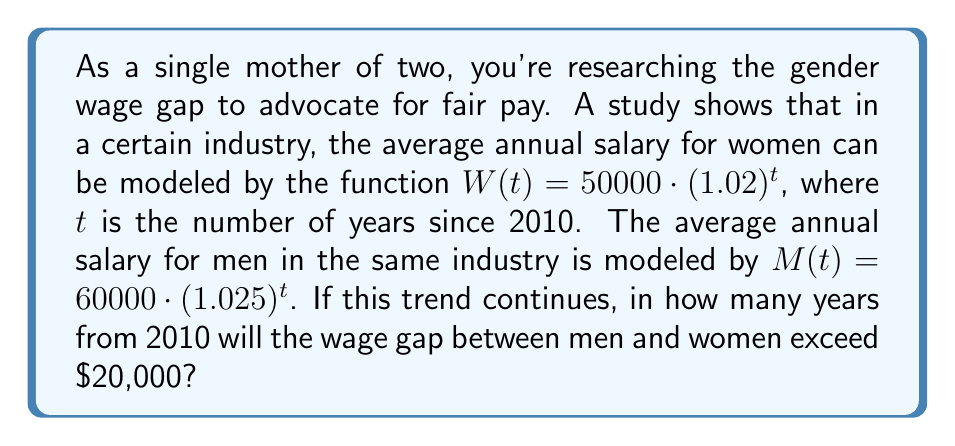Solve this math problem. To solve this problem, we need to follow these steps:

1) First, let's set up an inequality to represent when the wage gap exceeds $20,000:

   $M(t) - W(t) > 20000$

2) Substitute the given functions:

   $60000 \cdot (1.025)^t - 50000 \cdot (1.02)^t > 20000$

3) We need to solve this inequality for $t$. However, it's not easily solvable algebraically. We'll need to use a graphing calculator or spreadsheet to find the solution numerically.

4) Let's define a new function $f(t)$ as the difference between $M(t)$ and $W(t)$:

   $f(t) = 60000 \cdot (1.025)^t - 50000 \cdot (1.02)^t - 20000$

5) We need to find the smallest positive value of $t$ where $f(t) > 0$.

6) Using a graphing calculator or spreadsheet, we can find that $f(t)$ becomes positive between $t = 16$ and $t = 17$.

7) To be more precise, we can use a numerical method like bisection or Newton's method to find that $f(t) = 0$ when $t \approx 16.63$.

8) Since we're asked for the number of years as an integer, and we need the first year where the gap exceeds $20,000, we round up to 17.
Answer: The wage gap will exceed $20,000 in 17 years from 2010, which is in the year 2027. 